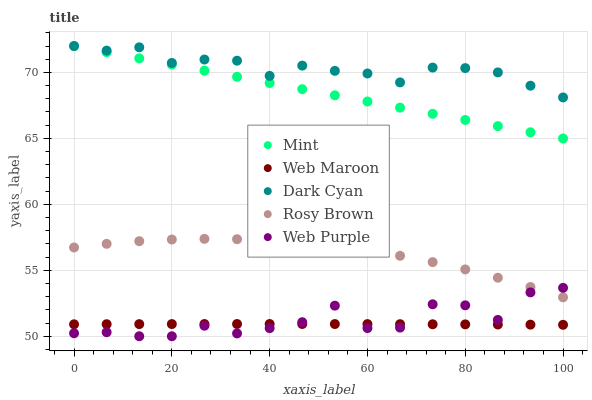Does Web Maroon have the minimum area under the curve?
Answer yes or no. Yes. Does Dark Cyan have the maximum area under the curve?
Answer yes or no. Yes. Does Web Purple have the minimum area under the curve?
Answer yes or no. No. Does Web Purple have the maximum area under the curve?
Answer yes or no. No. Is Mint the smoothest?
Answer yes or no. Yes. Is Web Purple the roughest?
Answer yes or no. Yes. Is Web Maroon the smoothest?
Answer yes or no. No. Is Web Maroon the roughest?
Answer yes or no. No. Does Web Purple have the lowest value?
Answer yes or no. Yes. Does Web Maroon have the lowest value?
Answer yes or no. No. Does Mint have the highest value?
Answer yes or no. Yes. Does Web Purple have the highest value?
Answer yes or no. No. Is Rosy Brown less than Dark Cyan?
Answer yes or no. Yes. Is Rosy Brown greater than Web Maroon?
Answer yes or no. Yes. Does Rosy Brown intersect Web Purple?
Answer yes or no. Yes. Is Rosy Brown less than Web Purple?
Answer yes or no. No. Is Rosy Brown greater than Web Purple?
Answer yes or no. No. Does Rosy Brown intersect Dark Cyan?
Answer yes or no. No. 